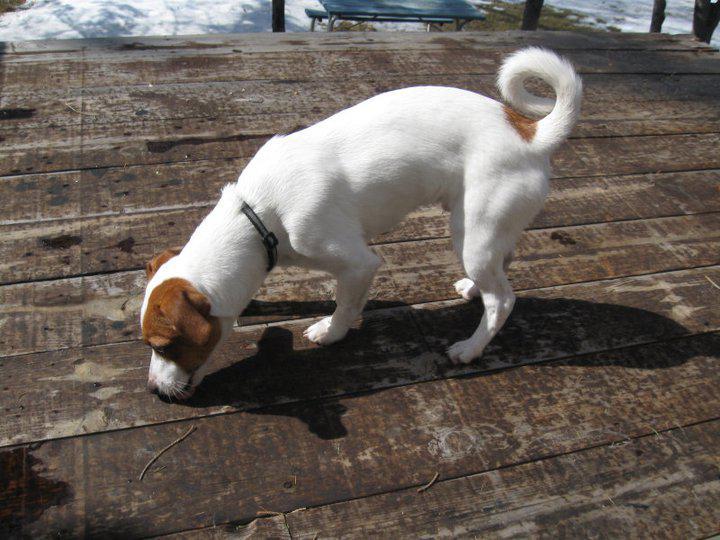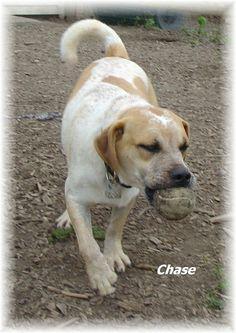The first image is the image on the left, the second image is the image on the right. Given the left and right images, does the statement "One image shows a dog with a tail curled inward, standing on all fours with its body in profile and wearing a collar." hold true? Answer yes or no. Yes. The first image is the image on the left, the second image is the image on the right. Considering the images on both sides, is "One dog is on a leash." valid? Answer yes or no. No. 